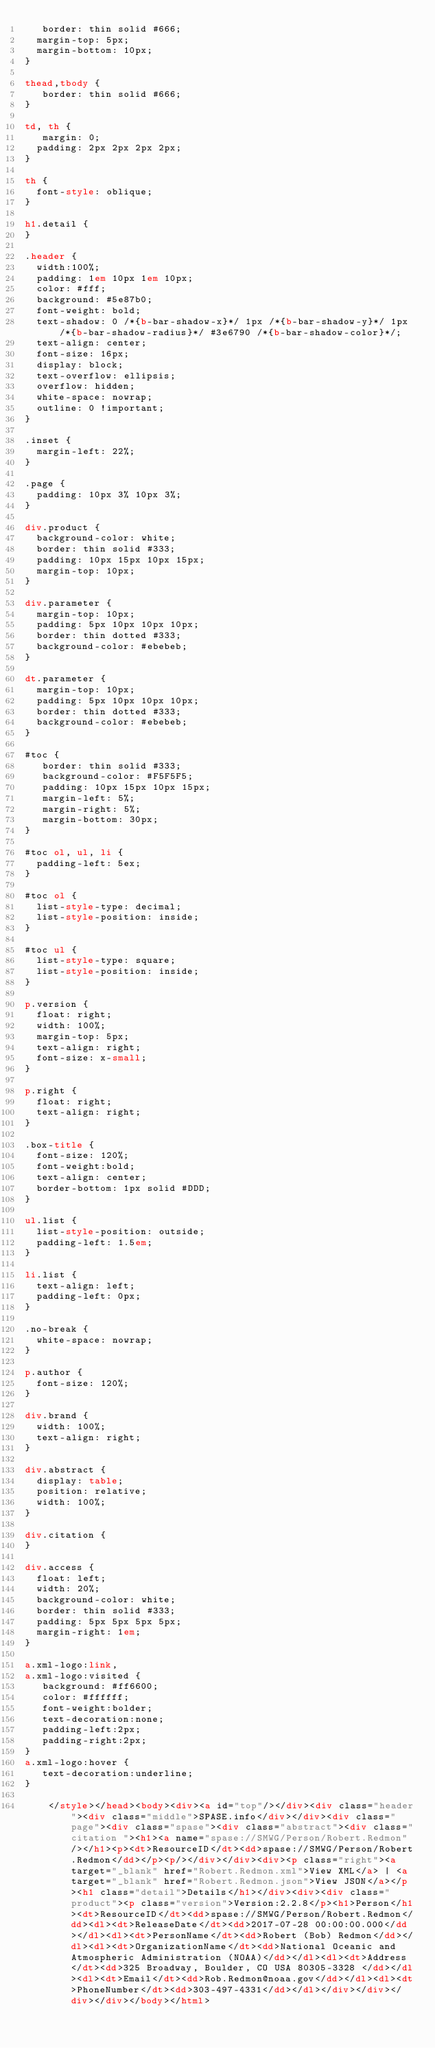<code> <loc_0><loc_0><loc_500><loc_500><_HTML_>   border: thin solid #666;
	margin-top: 5px;
	margin-bottom: 10px;
}

thead,tbody {
   border: thin solid #666;
}

td, th {
   margin: 0;
	padding: 2px 2px 2px 2px;
}

th {
	font-style: oblique;
}

h1.detail {
}

.header {
	width:100%;
	padding: 1em 10px 1em 10px;
	color: #fff;
	background: #5e87b0;
	font-weight: bold;
	text-shadow: 0 /*{b-bar-shadow-x}*/ 1px /*{b-bar-shadow-y}*/ 1px /*{b-bar-shadow-radius}*/ #3e6790 /*{b-bar-shadow-color}*/;
	text-align: center;
	font-size: 16px;
	display: block;
	text-overflow: ellipsis;
	overflow: hidden;
	white-space: nowrap;
	outline: 0 !important;
}

.inset {
	margin-left: 22%;
}

.page {
	padding: 10px 3% 10px 3%;
}

div.product {
	background-color: white;
	border: thin solid #333;
	padding: 10px 15px 10px 15px;
	margin-top: 10px;
}

div.parameter {
	margin-top: 10px;
	padding: 5px 10px 10px 10px;
	border: thin dotted #333;
	background-color: #ebebeb;
}

dt.parameter {
	margin-top: 10px;
	padding: 5px 10px 10px 10px;
	border: thin dotted #333;
	background-color: #ebebeb;
}

#toc {
   border: thin solid #333;
   background-color: #F5F5F5; 
   padding: 10px 15px 10px 15px;
   margin-left: 5%;
   margin-right: 5%;
   margin-bottom: 30px;
}

#toc ol, ul, li {
	padding-left: 5ex;
}

#toc ol {
	list-style-type: decimal;
	list-style-position: inside; 
}

#toc ul {
	list-style-type: square;
	list-style-position: inside; 
}

p.version {
  float: right;
  width: 100%;
  margin-top: 5px;
  text-align: right;
  font-size: x-small;
}

p.right {
  float: right;
  text-align: right;
}

.box-title {
	font-size: 120%;
	font-weight:bold;
	text-align: center;
	border-bottom: 1px solid #DDD;
}

ul.list {
	list-style-position: outside;
	padding-left: 1.5em;
}

li.list {
	text-align: left;
	padding-left: 0px;
}

.no-break {
	white-space: nowrap;
}

p.author {
	font-size: 120%;
}

div.brand {
	width: 100%;
	text-align: right;
}

div.abstract {
	display: table;
	position: relative;
	width: 100%;
}

div.citation {
}

div.access {
	float: left;
	width: 20%;
	background-color: white;
	border: thin solid #333;
	padding: 5px 5px 5px 5px;
	margin-right: 1em;
}

a.xml-logo:link,
a.xml-logo:visited {
   background: #ff6600;
   color: #ffffff;
   font-weight:bolder; 
   text-decoration:none; 
   padding-left:2px;
   padding-right:2px;
}
a.xml-logo:hover {
   text-decoration:underline; 
}

	  </style></head><body><div><a id="top"/></div><div class="header"><div class="middle">SPASE.info</div></div><div class="page"><div class="spase"><div class="abstract"><div class="citation "><h1><a name="spase://SMWG/Person/Robert.Redmon"/></h1><p><dt>ResourceID</dt><dd>spase://SMWG/Person/Robert.Redmon</dd></p><p/></div></div><div><p class="right"><a target="_blank" href="Robert.Redmon.xml">View XML</a> | <a target="_blank" href="Robert.Redmon.json">View JSON</a></p><h1 class="detail">Details</h1></div><div><div class="product"><p class="version">Version:2.2.8</p><h1>Person</h1><dt>ResourceID</dt><dd>spase://SMWG/Person/Robert.Redmon</dd><dl><dt>ReleaseDate</dt><dd>2017-07-28 00:00:00.000</dd></dl><dl><dt>PersonName</dt><dd>Robert (Bob) Redmon</dd></dl><dl><dt>OrganizationName</dt><dd>National Oceanic and Atmospheric Administration (NOAA)</dd></dl><dl><dt>Address</dt><dd>325 Broadway, Boulder, CO USA 80305-3328 </dd></dl><dl><dt>Email</dt><dd>Rob.Redmon@noaa.gov</dd></dl><dl><dt>PhoneNumber</dt><dd>303-497-4331</dd></dl></div></div></div></div></body></html>
</code> 